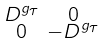Convert formula to latex. <formula><loc_0><loc_0><loc_500><loc_500>\begin{smallmatrix} D ^ { g _ { \tau } } & 0 \\ 0 & - D ^ { g _ { \tau } } \end{smallmatrix}</formula> 